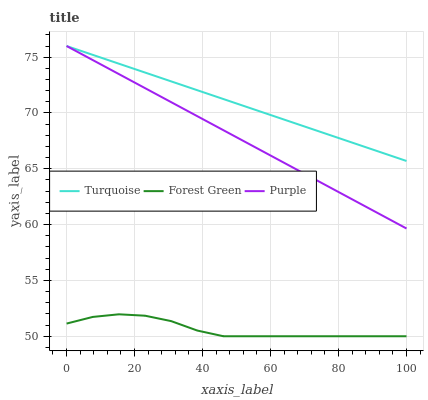Does Forest Green have the minimum area under the curve?
Answer yes or no. Yes. Does Turquoise have the maximum area under the curve?
Answer yes or no. Yes. Does Turquoise have the minimum area under the curve?
Answer yes or no. No. Does Forest Green have the maximum area under the curve?
Answer yes or no. No. Is Turquoise the smoothest?
Answer yes or no. Yes. Is Forest Green the roughest?
Answer yes or no. Yes. Is Forest Green the smoothest?
Answer yes or no. No. Is Turquoise the roughest?
Answer yes or no. No. Does Forest Green have the lowest value?
Answer yes or no. Yes. Does Turquoise have the lowest value?
Answer yes or no. No. Does Turquoise have the highest value?
Answer yes or no. Yes. Does Forest Green have the highest value?
Answer yes or no. No. Is Forest Green less than Turquoise?
Answer yes or no. Yes. Is Purple greater than Forest Green?
Answer yes or no. Yes. Does Purple intersect Turquoise?
Answer yes or no. Yes. Is Purple less than Turquoise?
Answer yes or no. No. Is Purple greater than Turquoise?
Answer yes or no. No. Does Forest Green intersect Turquoise?
Answer yes or no. No. 